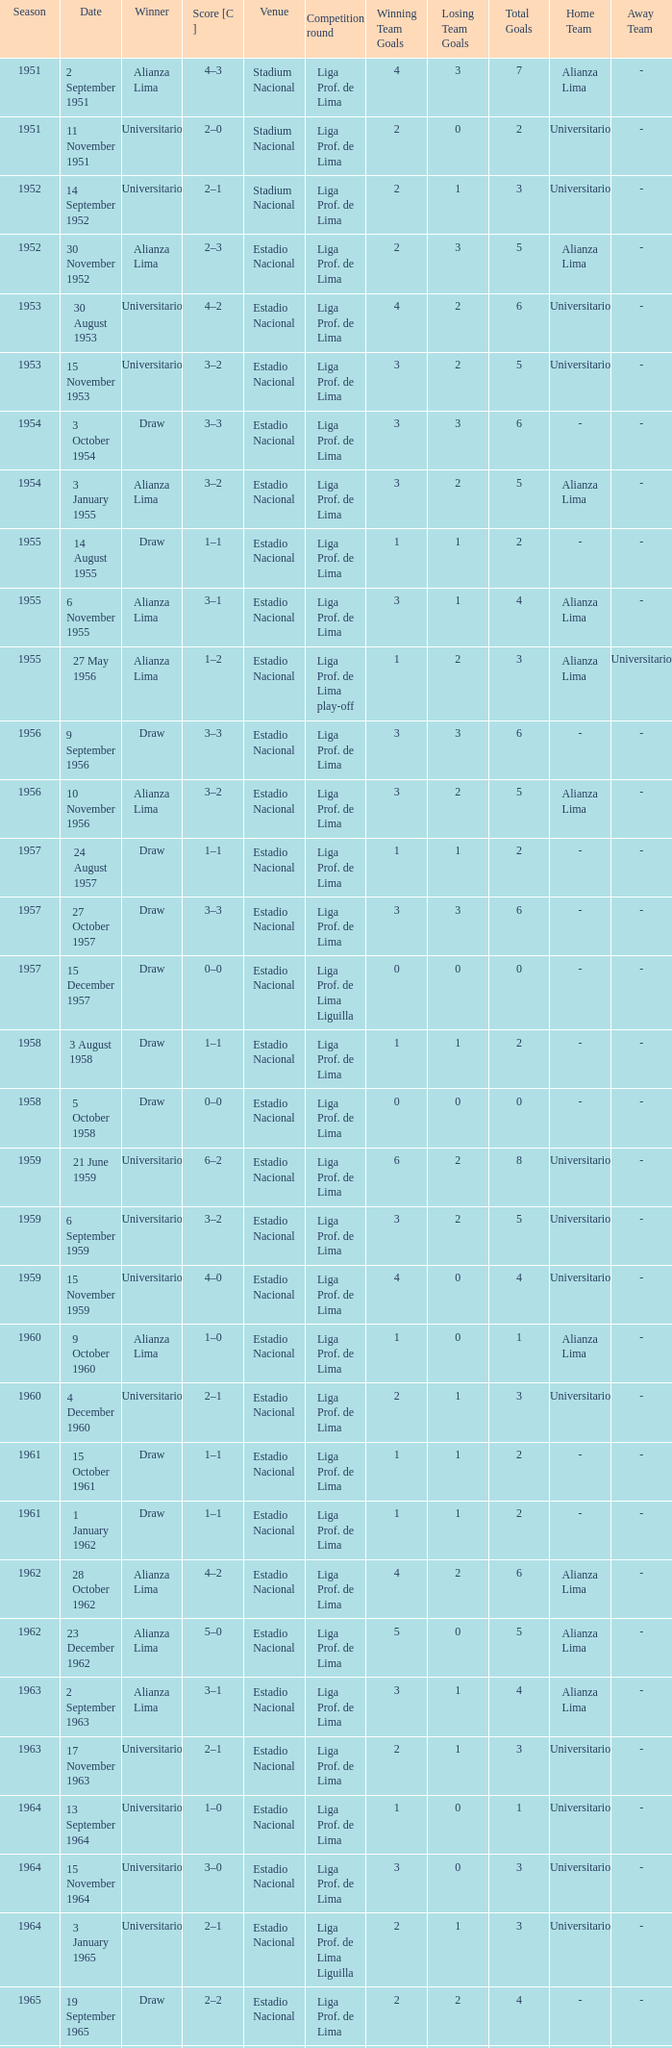What is the most recent season with a date of 27 October 1957? 1957.0. 